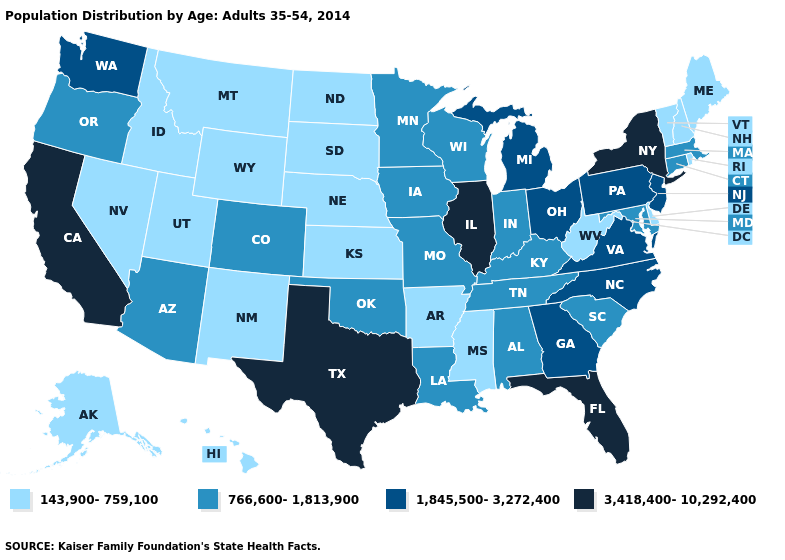Name the states that have a value in the range 143,900-759,100?
Keep it brief. Alaska, Arkansas, Delaware, Hawaii, Idaho, Kansas, Maine, Mississippi, Montana, Nebraska, Nevada, New Hampshire, New Mexico, North Dakota, Rhode Island, South Dakota, Utah, Vermont, West Virginia, Wyoming. Does the map have missing data?
Be succinct. No. What is the value of Virginia?
Write a very short answer. 1,845,500-3,272,400. Does Nevada have a lower value than Wyoming?
Short answer required. No. What is the lowest value in the South?
Short answer required. 143,900-759,100. Name the states that have a value in the range 766,600-1,813,900?
Quick response, please. Alabama, Arizona, Colorado, Connecticut, Indiana, Iowa, Kentucky, Louisiana, Maryland, Massachusetts, Minnesota, Missouri, Oklahoma, Oregon, South Carolina, Tennessee, Wisconsin. What is the value of South Dakota?
Quick response, please. 143,900-759,100. What is the value of Idaho?
Be succinct. 143,900-759,100. Which states have the lowest value in the West?
Be succinct. Alaska, Hawaii, Idaho, Montana, Nevada, New Mexico, Utah, Wyoming. Name the states that have a value in the range 143,900-759,100?
Quick response, please. Alaska, Arkansas, Delaware, Hawaii, Idaho, Kansas, Maine, Mississippi, Montana, Nebraska, Nevada, New Hampshire, New Mexico, North Dakota, Rhode Island, South Dakota, Utah, Vermont, West Virginia, Wyoming. Name the states that have a value in the range 766,600-1,813,900?
Quick response, please. Alabama, Arizona, Colorado, Connecticut, Indiana, Iowa, Kentucky, Louisiana, Maryland, Massachusetts, Minnesota, Missouri, Oklahoma, Oregon, South Carolina, Tennessee, Wisconsin. Does Vermont have the lowest value in the Northeast?
Be succinct. Yes. Name the states that have a value in the range 1,845,500-3,272,400?
Be succinct. Georgia, Michigan, New Jersey, North Carolina, Ohio, Pennsylvania, Virginia, Washington. Name the states that have a value in the range 143,900-759,100?
Quick response, please. Alaska, Arkansas, Delaware, Hawaii, Idaho, Kansas, Maine, Mississippi, Montana, Nebraska, Nevada, New Hampshire, New Mexico, North Dakota, Rhode Island, South Dakota, Utah, Vermont, West Virginia, Wyoming. Which states hav the highest value in the South?
Quick response, please. Florida, Texas. 